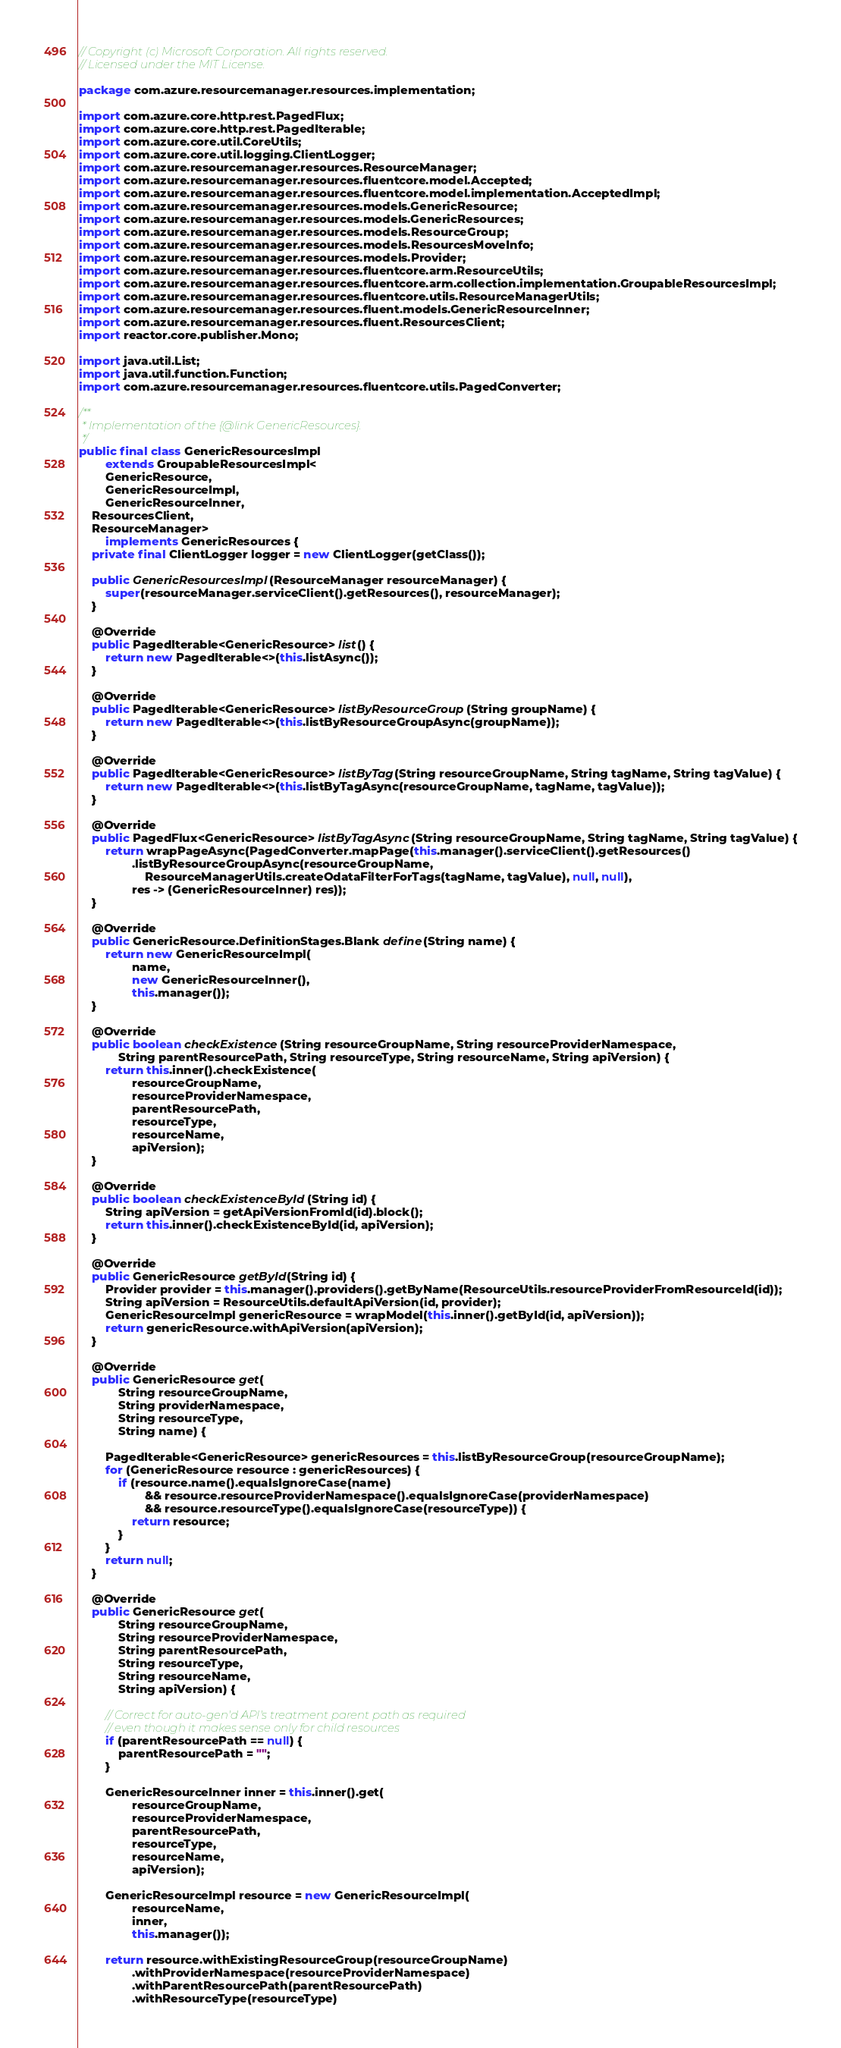<code> <loc_0><loc_0><loc_500><loc_500><_Java_>// Copyright (c) Microsoft Corporation. All rights reserved.
// Licensed under the MIT License.

package com.azure.resourcemanager.resources.implementation;

import com.azure.core.http.rest.PagedFlux;
import com.azure.core.http.rest.PagedIterable;
import com.azure.core.util.CoreUtils;
import com.azure.core.util.logging.ClientLogger;
import com.azure.resourcemanager.resources.ResourceManager;
import com.azure.resourcemanager.resources.fluentcore.model.Accepted;
import com.azure.resourcemanager.resources.fluentcore.model.implementation.AcceptedImpl;
import com.azure.resourcemanager.resources.models.GenericResource;
import com.azure.resourcemanager.resources.models.GenericResources;
import com.azure.resourcemanager.resources.models.ResourceGroup;
import com.azure.resourcemanager.resources.models.ResourcesMoveInfo;
import com.azure.resourcemanager.resources.models.Provider;
import com.azure.resourcemanager.resources.fluentcore.arm.ResourceUtils;
import com.azure.resourcemanager.resources.fluentcore.arm.collection.implementation.GroupableResourcesImpl;
import com.azure.resourcemanager.resources.fluentcore.utils.ResourceManagerUtils;
import com.azure.resourcemanager.resources.fluent.models.GenericResourceInner;
import com.azure.resourcemanager.resources.fluent.ResourcesClient;
import reactor.core.publisher.Mono;

import java.util.List;
import java.util.function.Function;
import com.azure.resourcemanager.resources.fluentcore.utils.PagedConverter;

/**
 * Implementation of the {@link GenericResources}.
 */
public final class GenericResourcesImpl
        extends GroupableResourcesImpl<
        GenericResource,
        GenericResourceImpl,
        GenericResourceInner,
    ResourcesClient,
    ResourceManager>
        implements GenericResources {
    private final ClientLogger logger = new ClientLogger(getClass());

    public GenericResourcesImpl(ResourceManager resourceManager) {
        super(resourceManager.serviceClient().getResources(), resourceManager);
    }

    @Override
    public PagedIterable<GenericResource> list() {
        return new PagedIterable<>(this.listAsync());
    }

    @Override
    public PagedIterable<GenericResource> listByResourceGroup(String groupName) {
        return new PagedIterable<>(this.listByResourceGroupAsync(groupName));
    }

    @Override
    public PagedIterable<GenericResource> listByTag(String resourceGroupName, String tagName, String tagValue) {
        return new PagedIterable<>(this.listByTagAsync(resourceGroupName, tagName, tagValue));
    }

    @Override
    public PagedFlux<GenericResource> listByTagAsync(String resourceGroupName, String tagName, String tagValue) {
        return wrapPageAsync(PagedConverter.mapPage(this.manager().serviceClient().getResources()
                .listByResourceGroupAsync(resourceGroupName,
                    ResourceManagerUtils.createOdataFilterForTags(tagName, tagValue), null, null),
                res -> (GenericResourceInner) res));
    }

    @Override
    public GenericResource.DefinitionStages.Blank define(String name) {
        return new GenericResourceImpl(
                name,
                new GenericResourceInner(),
                this.manager());
    }

    @Override
    public boolean checkExistence(String resourceGroupName, String resourceProviderNamespace,
            String parentResourcePath, String resourceType, String resourceName, String apiVersion) {
        return this.inner().checkExistence(
                resourceGroupName,
                resourceProviderNamespace,
                parentResourcePath,
                resourceType,
                resourceName,
                apiVersion);
    }

    @Override
    public boolean checkExistenceById(String id) {
        String apiVersion = getApiVersionFromId(id).block();
        return this.inner().checkExistenceById(id, apiVersion);
    }

    @Override
    public GenericResource getById(String id) {
        Provider provider = this.manager().providers().getByName(ResourceUtils.resourceProviderFromResourceId(id));
        String apiVersion = ResourceUtils.defaultApiVersion(id, provider);
        GenericResourceImpl genericResource = wrapModel(this.inner().getById(id, apiVersion));
        return genericResource.withApiVersion(apiVersion);
    }

    @Override
    public GenericResource get(
            String resourceGroupName,
            String providerNamespace,
            String resourceType,
            String name) {

        PagedIterable<GenericResource> genericResources = this.listByResourceGroup(resourceGroupName);
        for (GenericResource resource : genericResources) {
            if (resource.name().equalsIgnoreCase(name)
                    && resource.resourceProviderNamespace().equalsIgnoreCase(providerNamespace)
                    && resource.resourceType().equalsIgnoreCase(resourceType)) {
                return resource;
            }
        }
        return null;
    }

    @Override
    public GenericResource get(
            String resourceGroupName,
            String resourceProviderNamespace,
            String parentResourcePath,
            String resourceType,
            String resourceName,
            String apiVersion) {

        // Correct for auto-gen'd API's treatment parent path as required
        // even though it makes sense only for child resources
        if (parentResourcePath == null) {
            parentResourcePath = "";
        }

        GenericResourceInner inner = this.inner().get(
                resourceGroupName,
                resourceProviderNamespace,
                parentResourcePath,
                resourceType,
                resourceName,
                apiVersion);

        GenericResourceImpl resource = new GenericResourceImpl(
                resourceName,
                inner,
                this.manager());

        return resource.withExistingResourceGroup(resourceGroupName)
                .withProviderNamespace(resourceProviderNamespace)
                .withParentResourcePath(parentResourcePath)
                .withResourceType(resourceType)</code> 